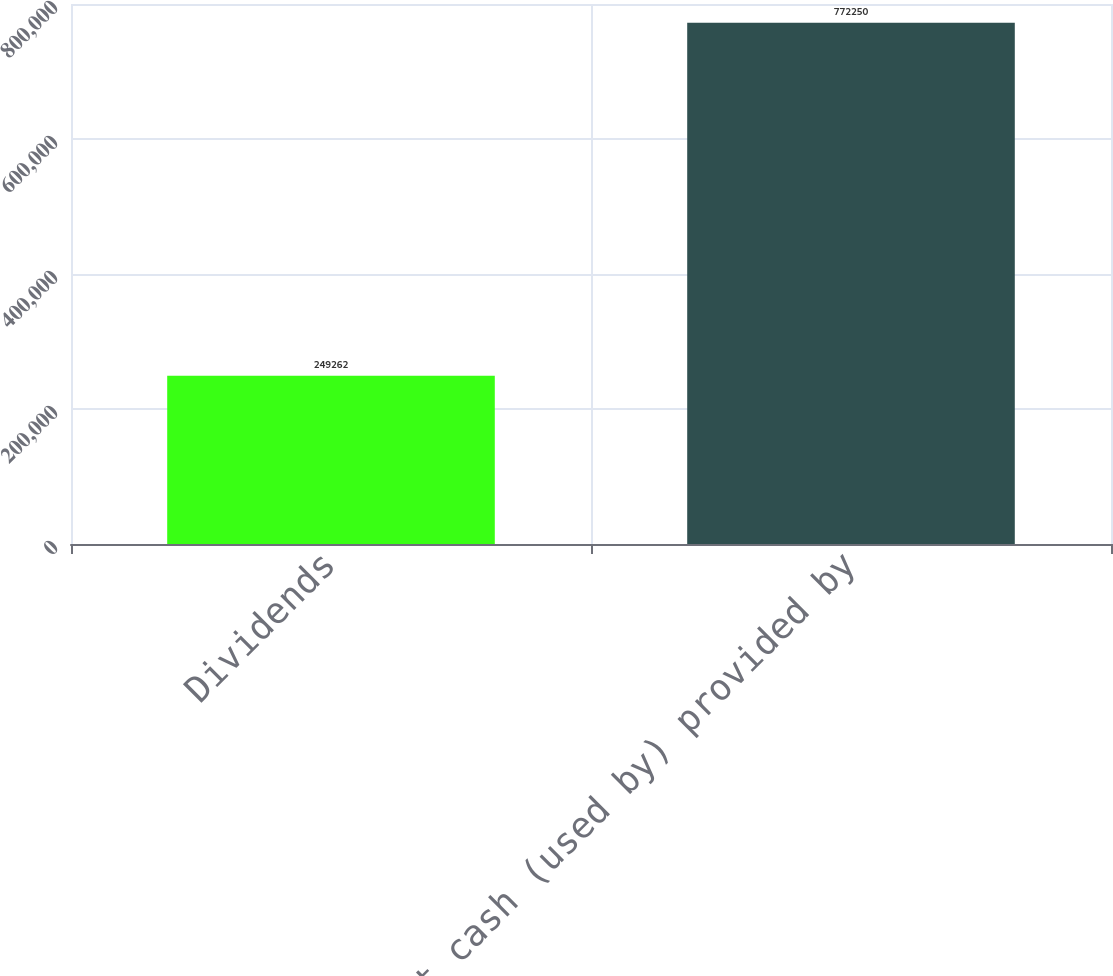<chart> <loc_0><loc_0><loc_500><loc_500><bar_chart><fcel>Dividends<fcel>Net cash (used by) provided by<nl><fcel>249262<fcel>772250<nl></chart> 